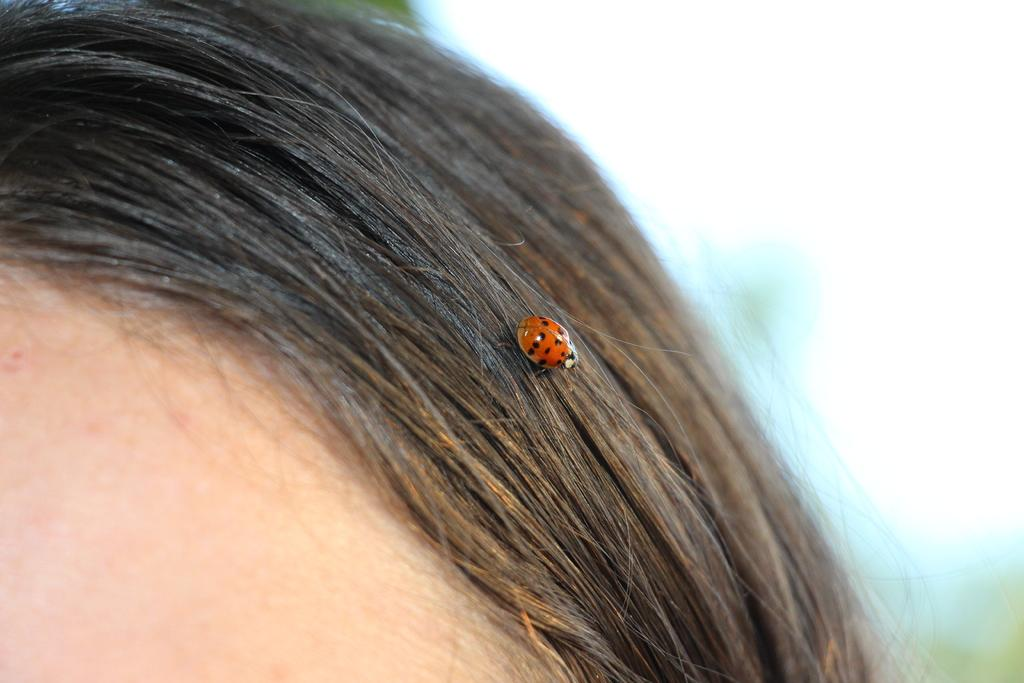What is the main subject of focus of the image? The main focus of the image is a ladybug. Where is the ladybug located in the image? The ladybug is in the center of the image. What is the ladybug resting on? The ladybug is on the hair. How many feet does the ladybug have in the image? Ladybugs have six legs, but the image does not show the legs of the ladybug, so we cannot determine the number of feet from the image. 